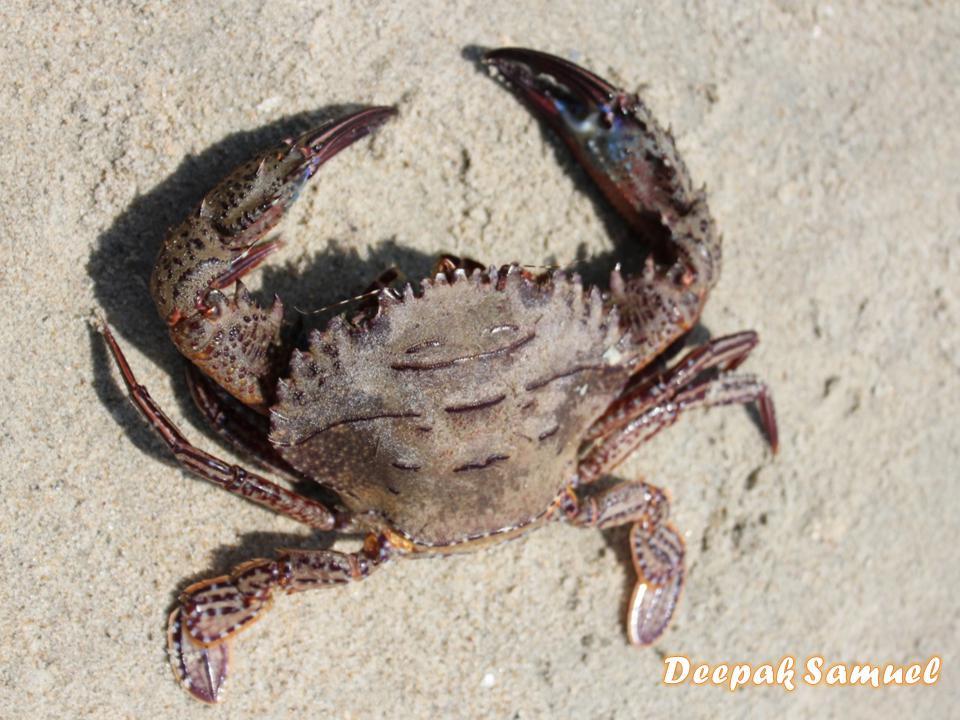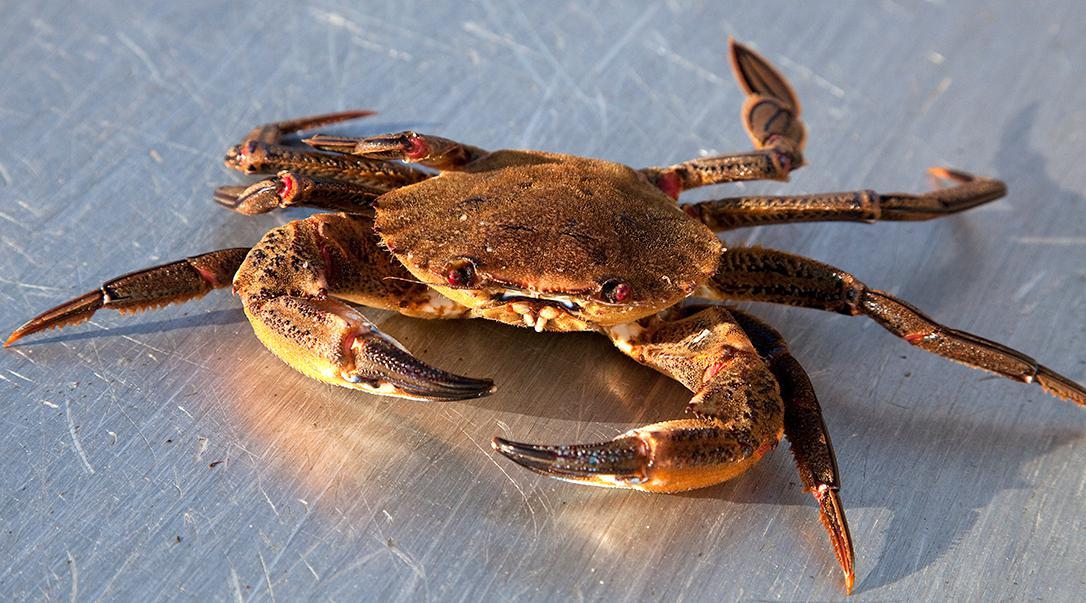The first image is the image on the left, the second image is the image on the right. For the images displayed, is the sentence "The left and right image contains the same number of crabs with at least one with blue claws." factually correct? Answer yes or no. Yes. The first image is the image on the left, the second image is the image on the right. Given the left and right images, does the statement "The left image contains a shell-up crab with its face at the top and its front claws above its head and both pointing inward." hold true? Answer yes or no. Yes. 